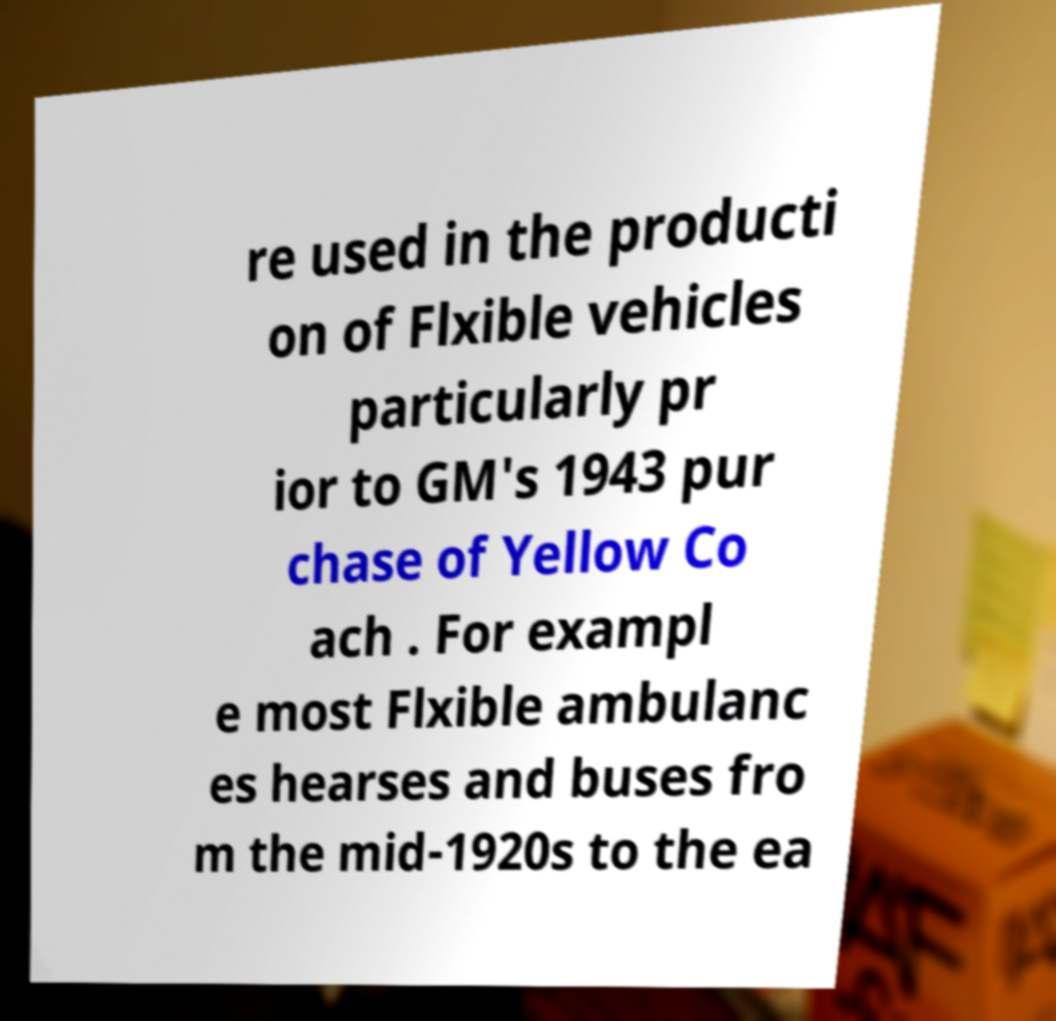I need the written content from this picture converted into text. Can you do that? re used in the producti on of Flxible vehicles particularly pr ior to GM's 1943 pur chase of Yellow Co ach . For exampl e most Flxible ambulanc es hearses and buses fro m the mid-1920s to the ea 